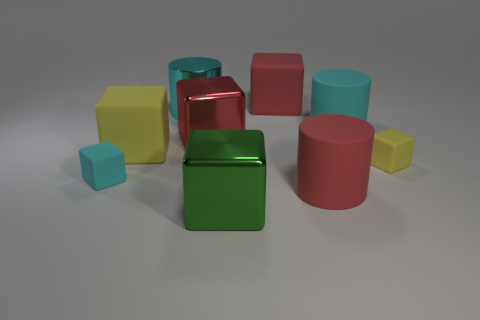There is a metal cylinder; is it the same color as the tiny matte thing on the left side of the green block?
Give a very brief answer. Yes. What is the material of the large green thing?
Make the answer very short. Metal. How many small things are red metallic things or red rubber things?
Your answer should be compact. 0. How many big cubes are on the right side of the red cylinder?
Provide a short and direct response. 0. Is there another large metal cylinder of the same color as the metal cylinder?
Offer a terse response. No. What is the shape of the yellow thing that is the same size as the red shiny cube?
Provide a succinct answer. Cube. How many brown objects are matte cubes or matte cylinders?
Ensure brevity in your answer.  0. What number of red rubber cubes are the same size as the red metallic thing?
Keep it short and to the point. 1. What is the shape of the big thing that is the same color as the big metal cylinder?
Offer a terse response. Cylinder. How many things are green blocks or large things that are on the right side of the red cylinder?
Keep it short and to the point. 2. 